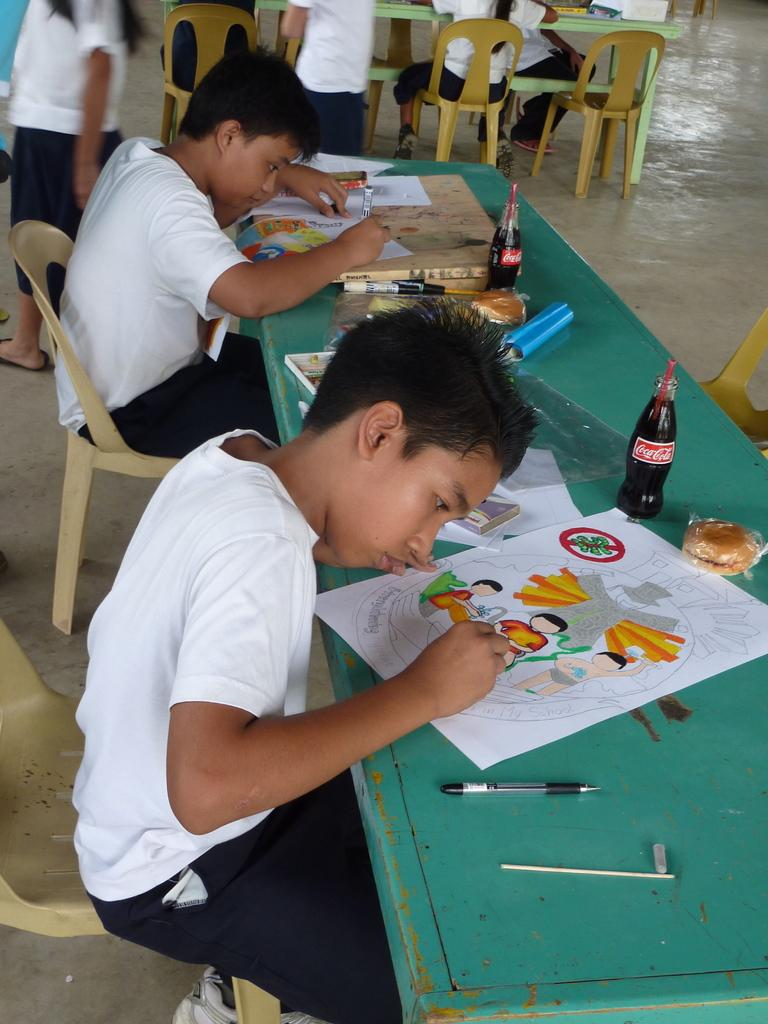What are the kids doing in the image? The kids are sitting on chairs and drawing on sheets in the image. What objects are on the table in the image? There are bottles, burgers, and pens on the table in the image. What arithmetic problem are the kids solving on the sheets? There is no indication in the image that the kids are solving an arithmetic problem; they are drawing on the sheets. Can you see a hose in the image? There is no hose present in the image. 